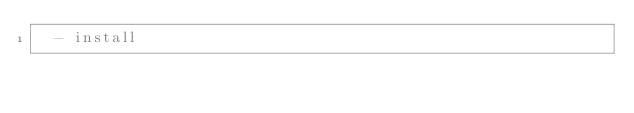Convert code to text. <code><loc_0><loc_0><loc_500><loc_500><_YAML_>  - install
</code> 